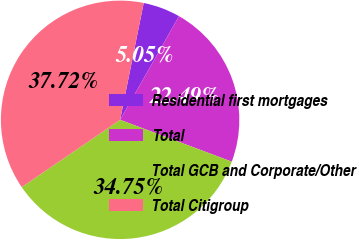Convert chart to OTSL. <chart><loc_0><loc_0><loc_500><loc_500><pie_chart><fcel>Residential first mortgages<fcel>Total<fcel>Total GCB and Corporate/Other<fcel>Total Citigroup<nl><fcel>5.05%<fcel>22.49%<fcel>34.75%<fcel>37.72%<nl></chart> 